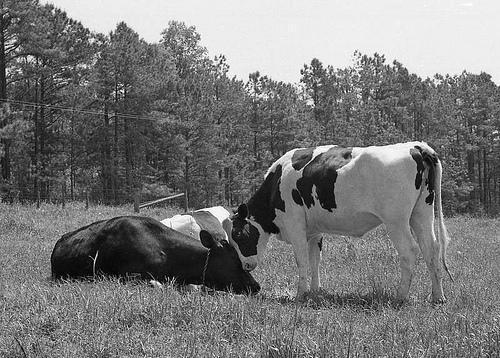How many cows are standing?
Give a very brief answer. 1. 